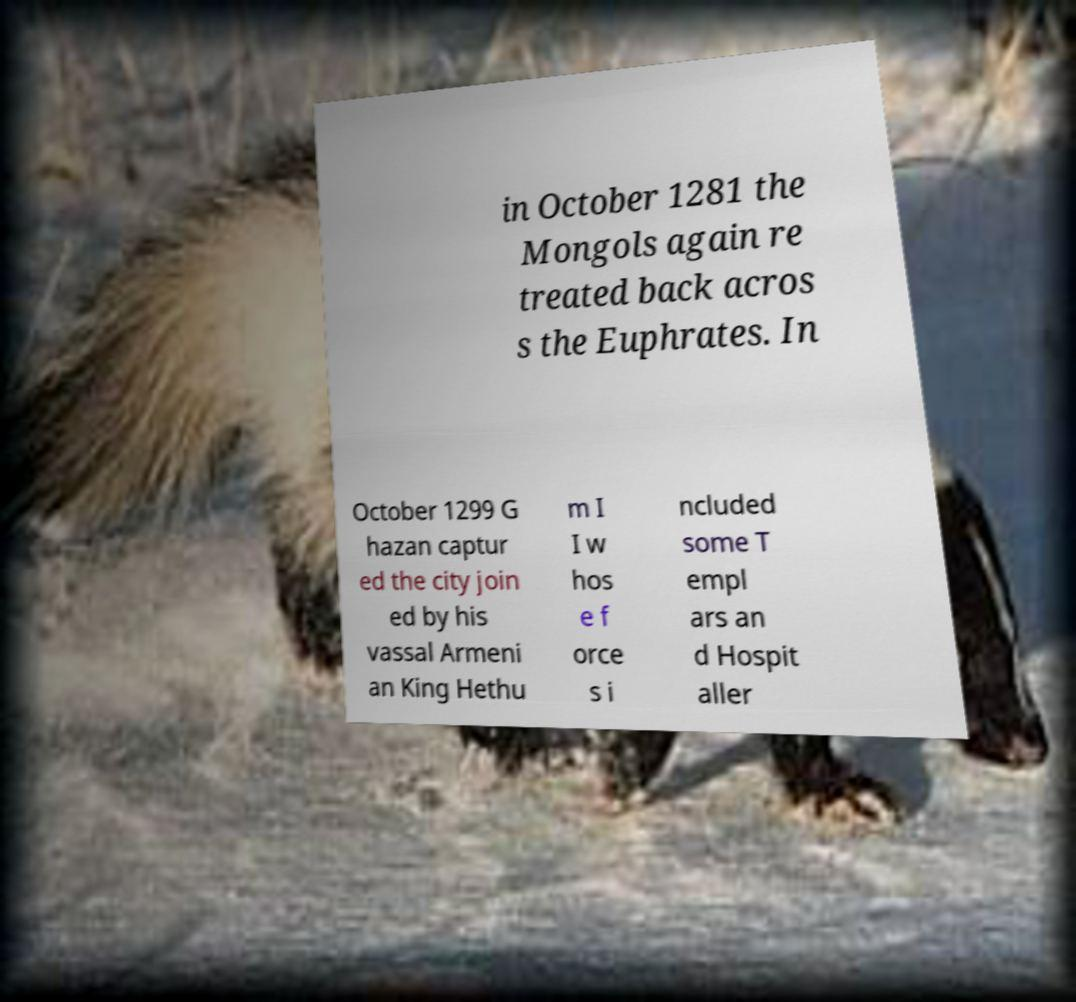Can you read and provide the text displayed in the image?This photo seems to have some interesting text. Can you extract and type it out for me? in October 1281 the Mongols again re treated back acros s the Euphrates. In October 1299 G hazan captur ed the city join ed by his vassal Armeni an King Hethu m I I w hos e f orce s i ncluded some T empl ars an d Hospit aller 